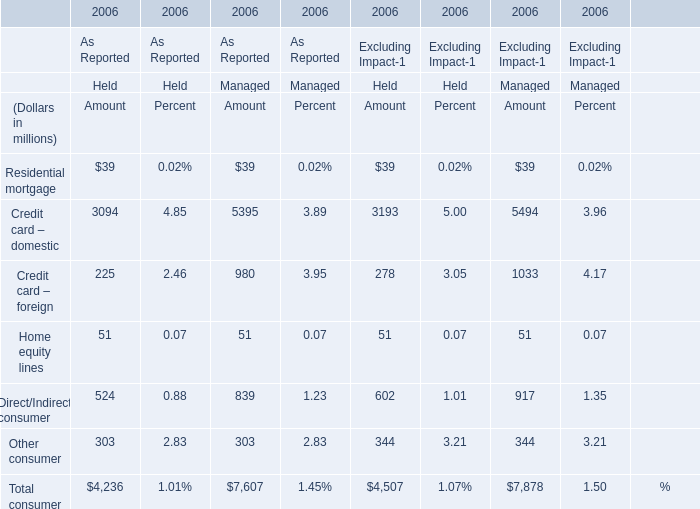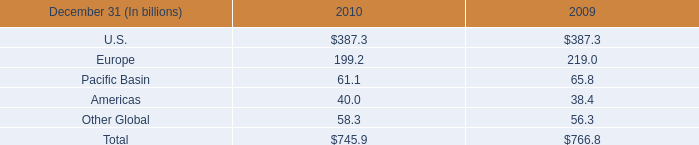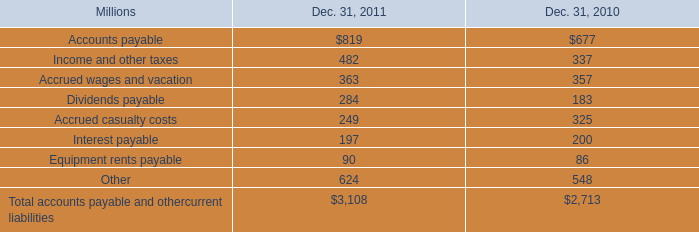assuming 2010 accrued casualty costs were completely repaired in the following year , ,what would the repairs and maintenance expense increase to for 2011 in millions? 
Computations: (325 + (2.2 * 1000))
Answer: 2525.0. 